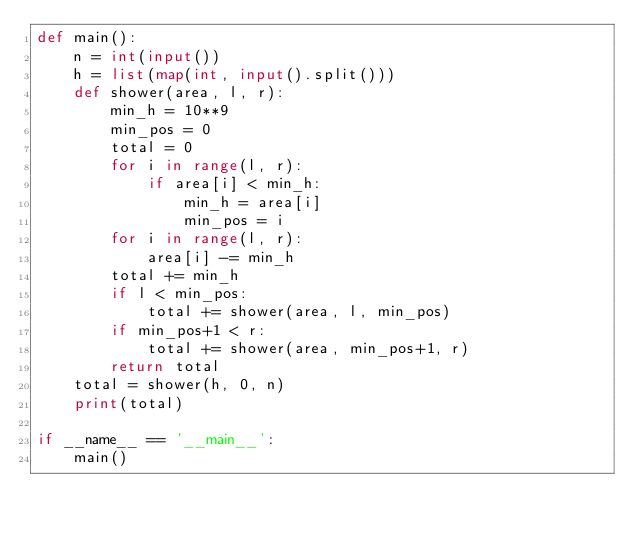Convert code to text. <code><loc_0><loc_0><loc_500><loc_500><_Python_>def main():
	n = int(input())
	h = list(map(int, input().split()))
	def shower(area, l, r):
		min_h = 10**9
		min_pos = 0
		total = 0
		for i in range(l, r):
			if area[i] < min_h:
				min_h = area[i]
				min_pos = i
		for i in range(l, r):
			area[i] -= min_h
		total += min_h
		if l < min_pos:
			total += shower(area, l, min_pos)
		if min_pos+1 < r:
			total += shower(area, min_pos+1, r)
		return total
	total = shower(h, 0, n)
	print(total)

if __name__ == '__main__':
    main()</code> 